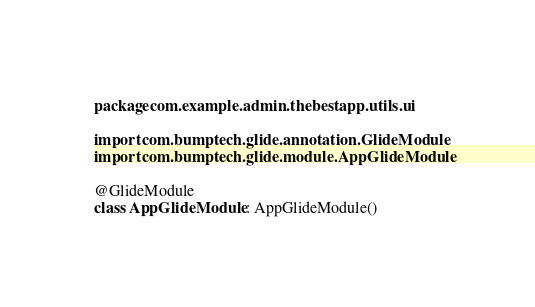Convert code to text. <code><loc_0><loc_0><loc_500><loc_500><_Kotlin_>package com.example.admin.thebestapp.utils.ui

import com.bumptech.glide.annotation.GlideModule
import com.bumptech.glide.module.AppGlideModule

@GlideModule
class AppGlideModule : AppGlideModule()</code> 